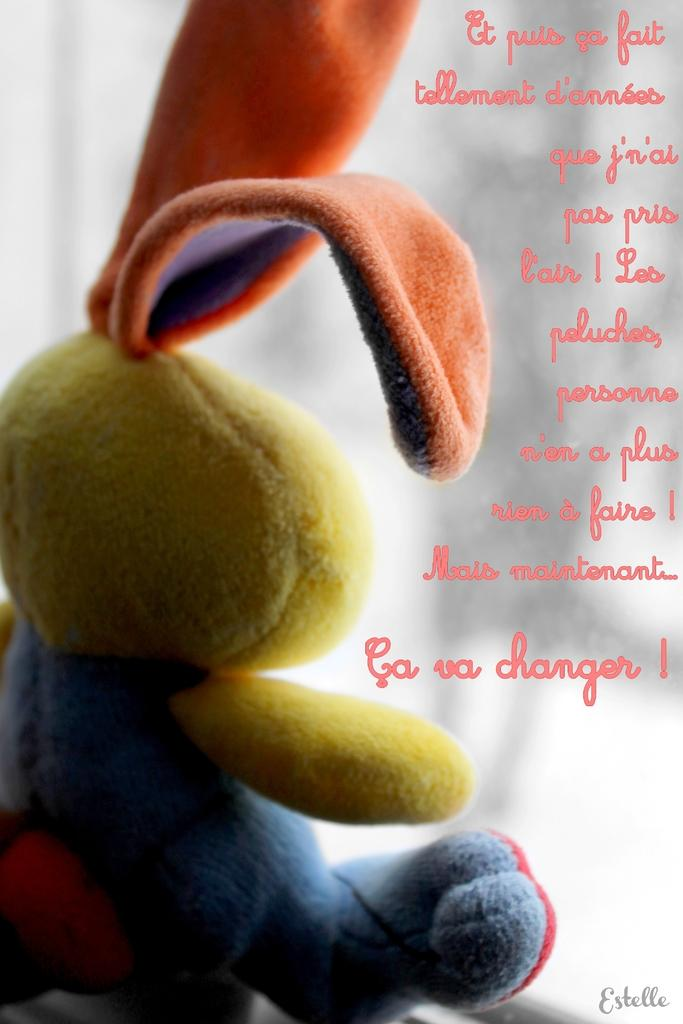What object can be seen in the image? There is a toy in the image. What is written on the toy? There is text written on the toy. What color is the background of the image? The background of the image is white. How many spiders are crawling on the toy in the image? There are no spiders present in the image; it only features a toy with text on it against a white background. 